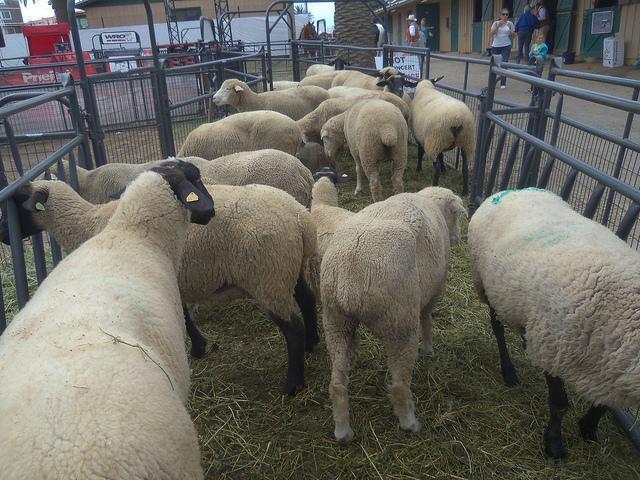What feature do these animals have?
From the following set of four choices, select the accurate answer to respond to the question.
Options: Wool, tusks, wings, antlers. Wool. 